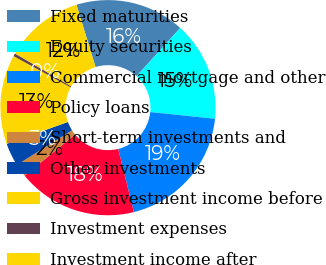<chart> <loc_0><loc_0><loc_500><loc_500><pie_chart><fcel>Fixed maturities<fcel>Equity securities<fcel>Commercial mortgage and other<fcel>Policy loans<fcel>Short-term investments and<fcel>Other investments<fcel>Gross investment income before<fcel>Investment expenses<fcel>Investment income after<nl><fcel>16.45%<fcel>14.93%<fcel>19.49%<fcel>17.97%<fcel>1.96%<fcel>3.48%<fcel>13.41%<fcel>0.44%<fcel>11.88%<nl></chart> 